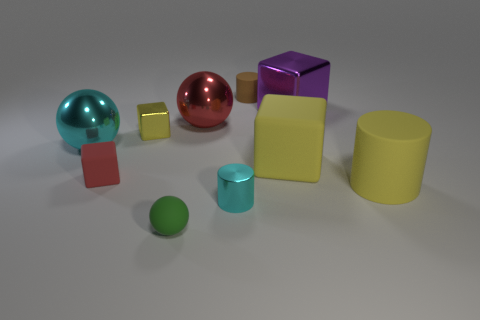Is the size of the metal cylinder the same as the red matte cube?
Your answer should be compact. Yes. What number of things are either cyan metal things or brown matte objects?
Provide a succinct answer. 3. Are there the same number of purple cubes that are to the left of the tiny red object and small purple rubber objects?
Your answer should be compact. Yes. Are there any metallic cubes in front of the red thing right of the thing in front of the cyan metal cylinder?
Provide a succinct answer. Yes. The cylinder that is made of the same material as the tiny yellow thing is what color?
Your answer should be compact. Cyan. Is the color of the tiny cylinder right of the tiny cyan cylinder the same as the big cylinder?
Provide a succinct answer. No. What number of spheres are either small brown rubber things or tiny green things?
Make the answer very short. 1. How big is the yellow matte block that is on the right side of the small cylinder in front of the sphere to the left of the tiny green matte thing?
Ensure brevity in your answer.  Large. The yellow shiny object that is the same size as the rubber sphere is what shape?
Ensure brevity in your answer.  Cube. What is the shape of the tiny cyan thing?
Offer a very short reply. Cylinder. 